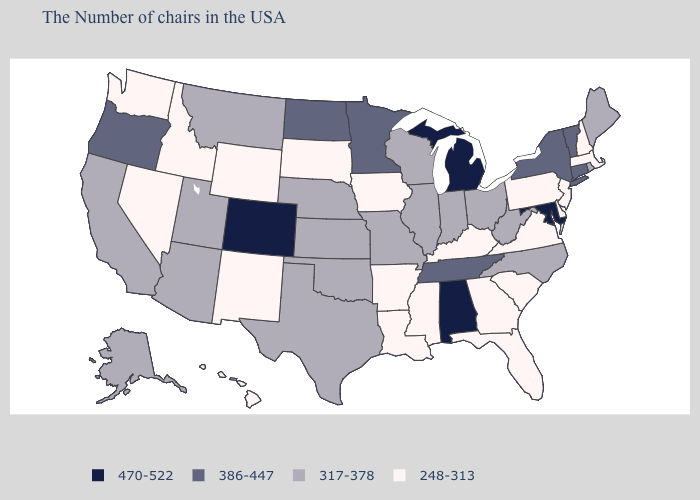Does South Dakota have the lowest value in the USA?
Answer briefly. Yes. Among the states that border Arizona , which have the lowest value?
Quick response, please. New Mexico, Nevada. Name the states that have a value in the range 317-378?
Keep it brief. Maine, Rhode Island, North Carolina, West Virginia, Ohio, Indiana, Wisconsin, Illinois, Missouri, Kansas, Nebraska, Oklahoma, Texas, Utah, Montana, Arizona, California, Alaska. Does the map have missing data?
Short answer required. No. Among the states that border South Carolina , which have the lowest value?
Answer briefly. Georgia. What is the highest value in the USA?
Quick response, please. 470-522. Which states have the highest value in the USA?
Keep it brief. Maryland, Michigan, Alabama, Colorado. Does the map have missing data?
Give a very brief answer. No. Which states have the lowest value in the USA?
Answer briefly. Massachusetts, New Hampshire, New Jersey, Delaware, Pennsylvania, Virginia, South Carolina, Florida, Georgia, Kentucky, Mississippi, Louisiana, Arkansas, Iowa, South Dakota, Wyoming, New Mexico, Idaho, Nevada, Washington, Hawaii. What is the value of Oregon?
Answer briefly. 386-447. Among the states that border Nebraska , which have the lowest value?
Write a very short answer. Iowa, South Dakota, Wyoming. Does South Carolina have the highest value in the USA?
Short answer required. No. What is the highest value in the USA?
Concise answer only. 470-522. What is the value of Kansas?
Be succinct. 317-378. Among the states that border Wyoming , does Montana have the highest value?
Concise answer only. No. 